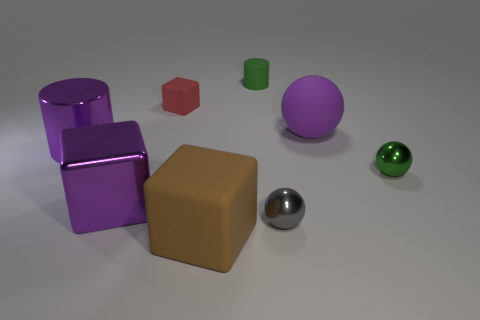Subtract all rubber balls. How many balls are left? 2 Add 1 small gray metallic things. How many objects exist? 9 Subtract 1 balls. How many balls are left? 2 Subtract all cylinders. How many objects are left? 6 Subtract all yellow blocks. Subtract all green spheres. How many blocks are left? 3 Add 8 small green spheres. How many small green spheres are left? 9 Add 1 metal spheres. How many metal spheres exist? 3 Subtract 0 cyan cylinders. How many objects are left? 8 Subtract all yellow metal objects. Subtract all large brown cubes. How many objects are left? 7 